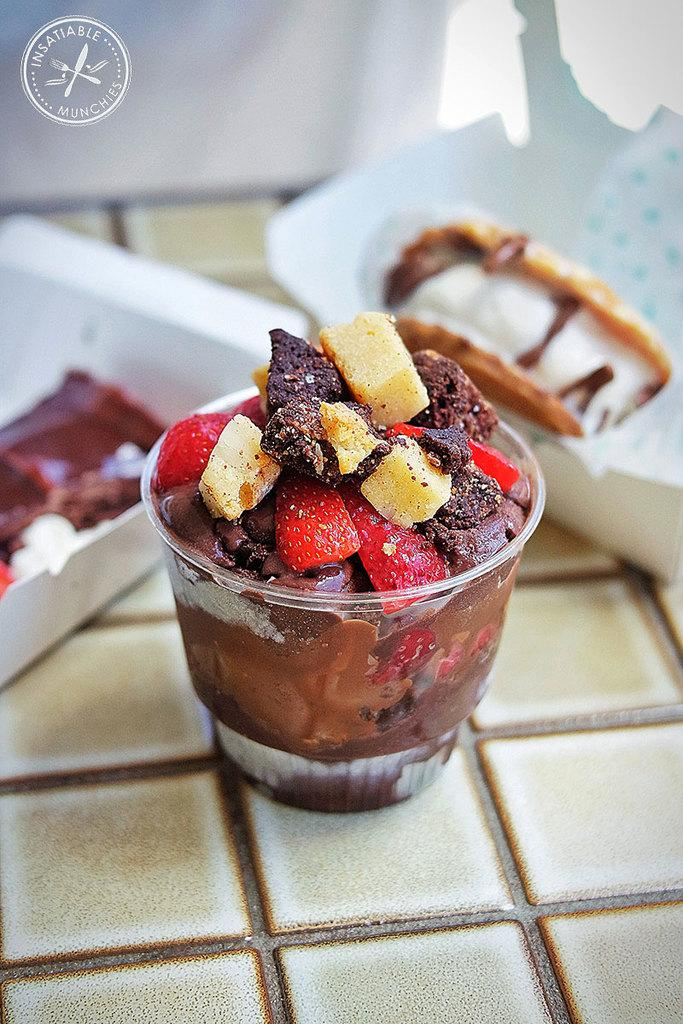What is present in the image that can hold liquids? There is a cup in the image that can hold liquids. What else can be seen in the image besides the cup? There is food in the image. Where are the cup and food located in the image? The cup and food are on a platform. What type of locket is hanging from the cup in the image? There is no locket present in the image; it only features a cup and food on a platform. 